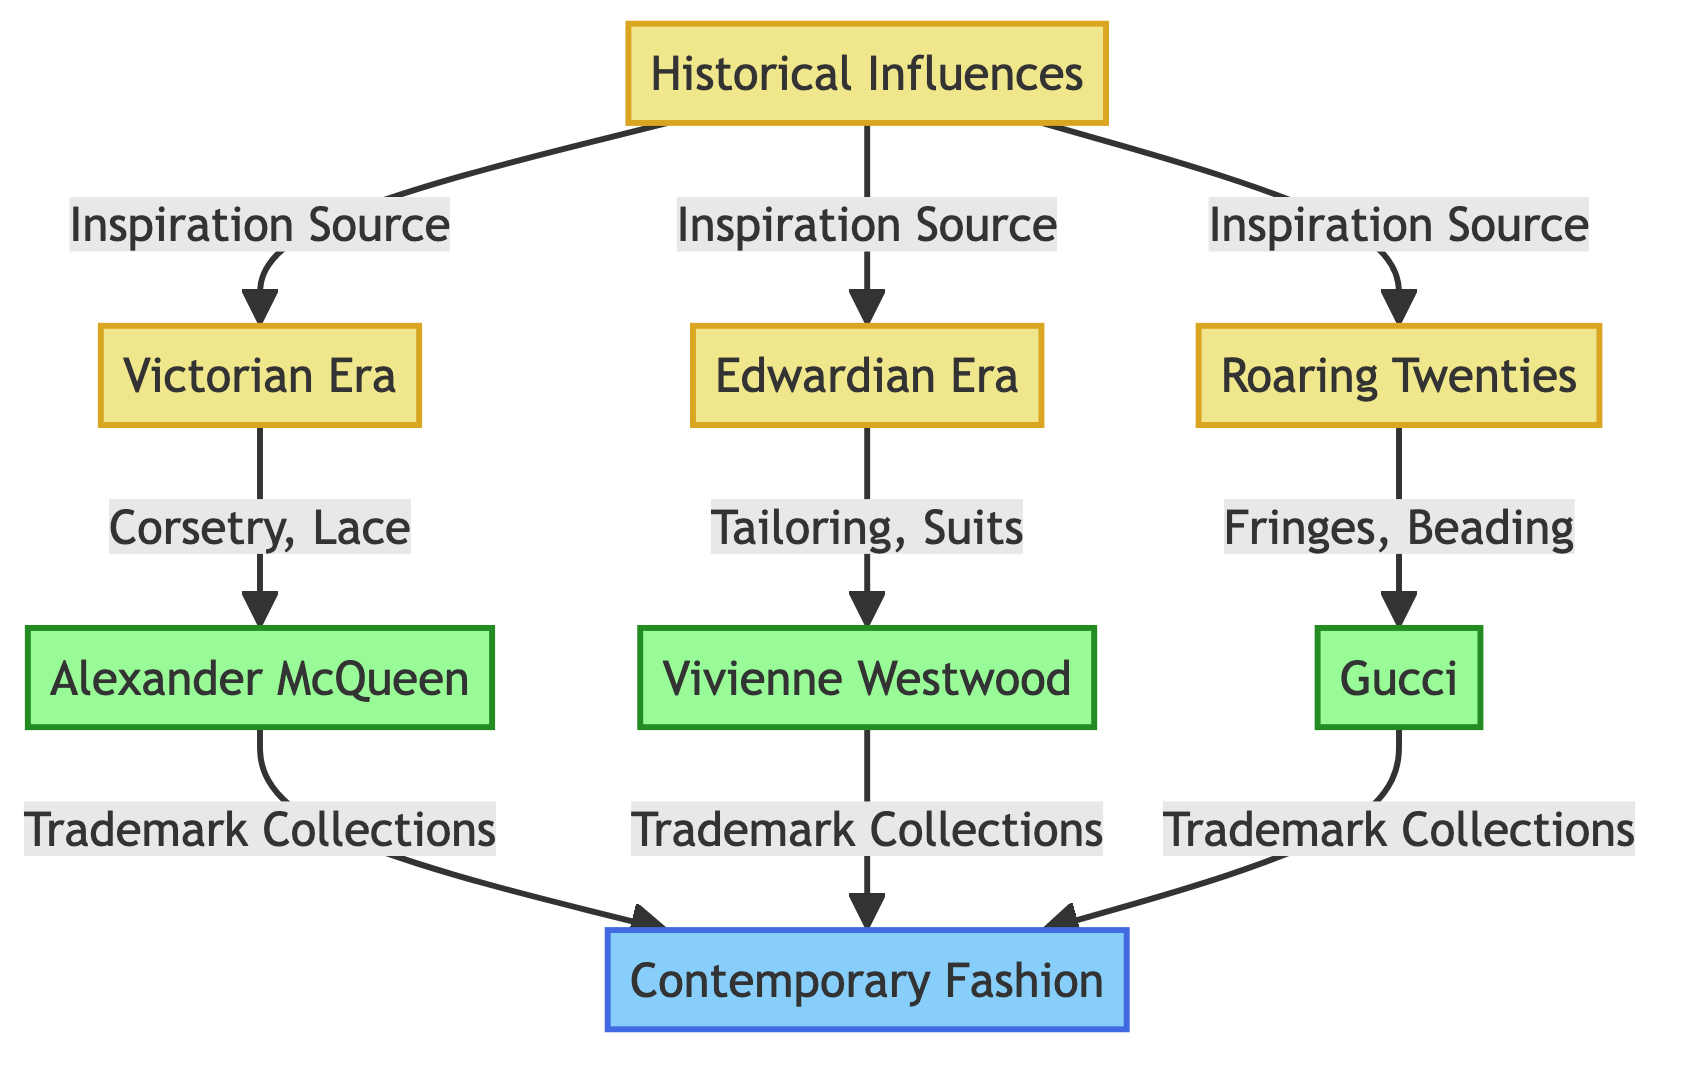What are the three historical influences mentioned in the diagram? The diagram lists three historical influences: the Victorian Era, Edwardian Era, and Roaring Twenties. These are specifically noted as direct inspirations for contemporary fashion. Therefore, the answer includes all three eras mentioned.
Answer: Victorian Era, Edwardian Era, Roaring Twenties How many modern designers are cited in the diagram? The diagram identifies three modern designers: Alexander McQueen, Vivienne Westwood, and Gucci. Counting these nodes gives the total number of modern designers mentioned.
Answer: 3 What is the inspiration source for Edwardian Era fashion in contemporary designers? The diagram indicates that the Edwardian Era influences modern designers through tailoring and suits, which is a direct relationship established in the flowchart. Thus, these two aspects are the specific inspirations linked to the Edwardian Era.
Answer: Tailoring, Suits Which designer is connected to Victorian Era inspirations? According to the flowchart, the designer that is connected to inspirations from the Victorian Era is Alexander McQueen. The connection is explicitly defined in the diagram through the arrows showing relationships.
Answer: Alexander McQueen What type of element is represented by the 'Contemporary Fashion' node? The 'Contemporary Fashion' node is categorized as a contemporary element in the diagram, indicating its role as a modern synthesis of historical influences. This classification is part of the structure defined in the visual mapping.
Answer: Contemporary Which historical era is associated with fringes and beading? The diagram specifies that fringes and beading are associated with the Roaring Twenties, as shown by the connecting line between that historical era and the modern designer Gucci, who draws from those elements.
Answer: Roaring Twenties How many total nodes are present in the diagram? By counting all nodes present in the flowchart, including historical influences, modern designers, and contemporary fashion, the total adds up to eight nodes. This total follows the node structure laid out in the diagram.
Answer: 8 Which designer is inspired by corsetry and lace? The diagram clarifies that Alexander McQueen is inspired by corsetry and lace, as established by the direct connection from the Victorian Era leading to this modern designer's collections.
Answer: Alexander McQueen 